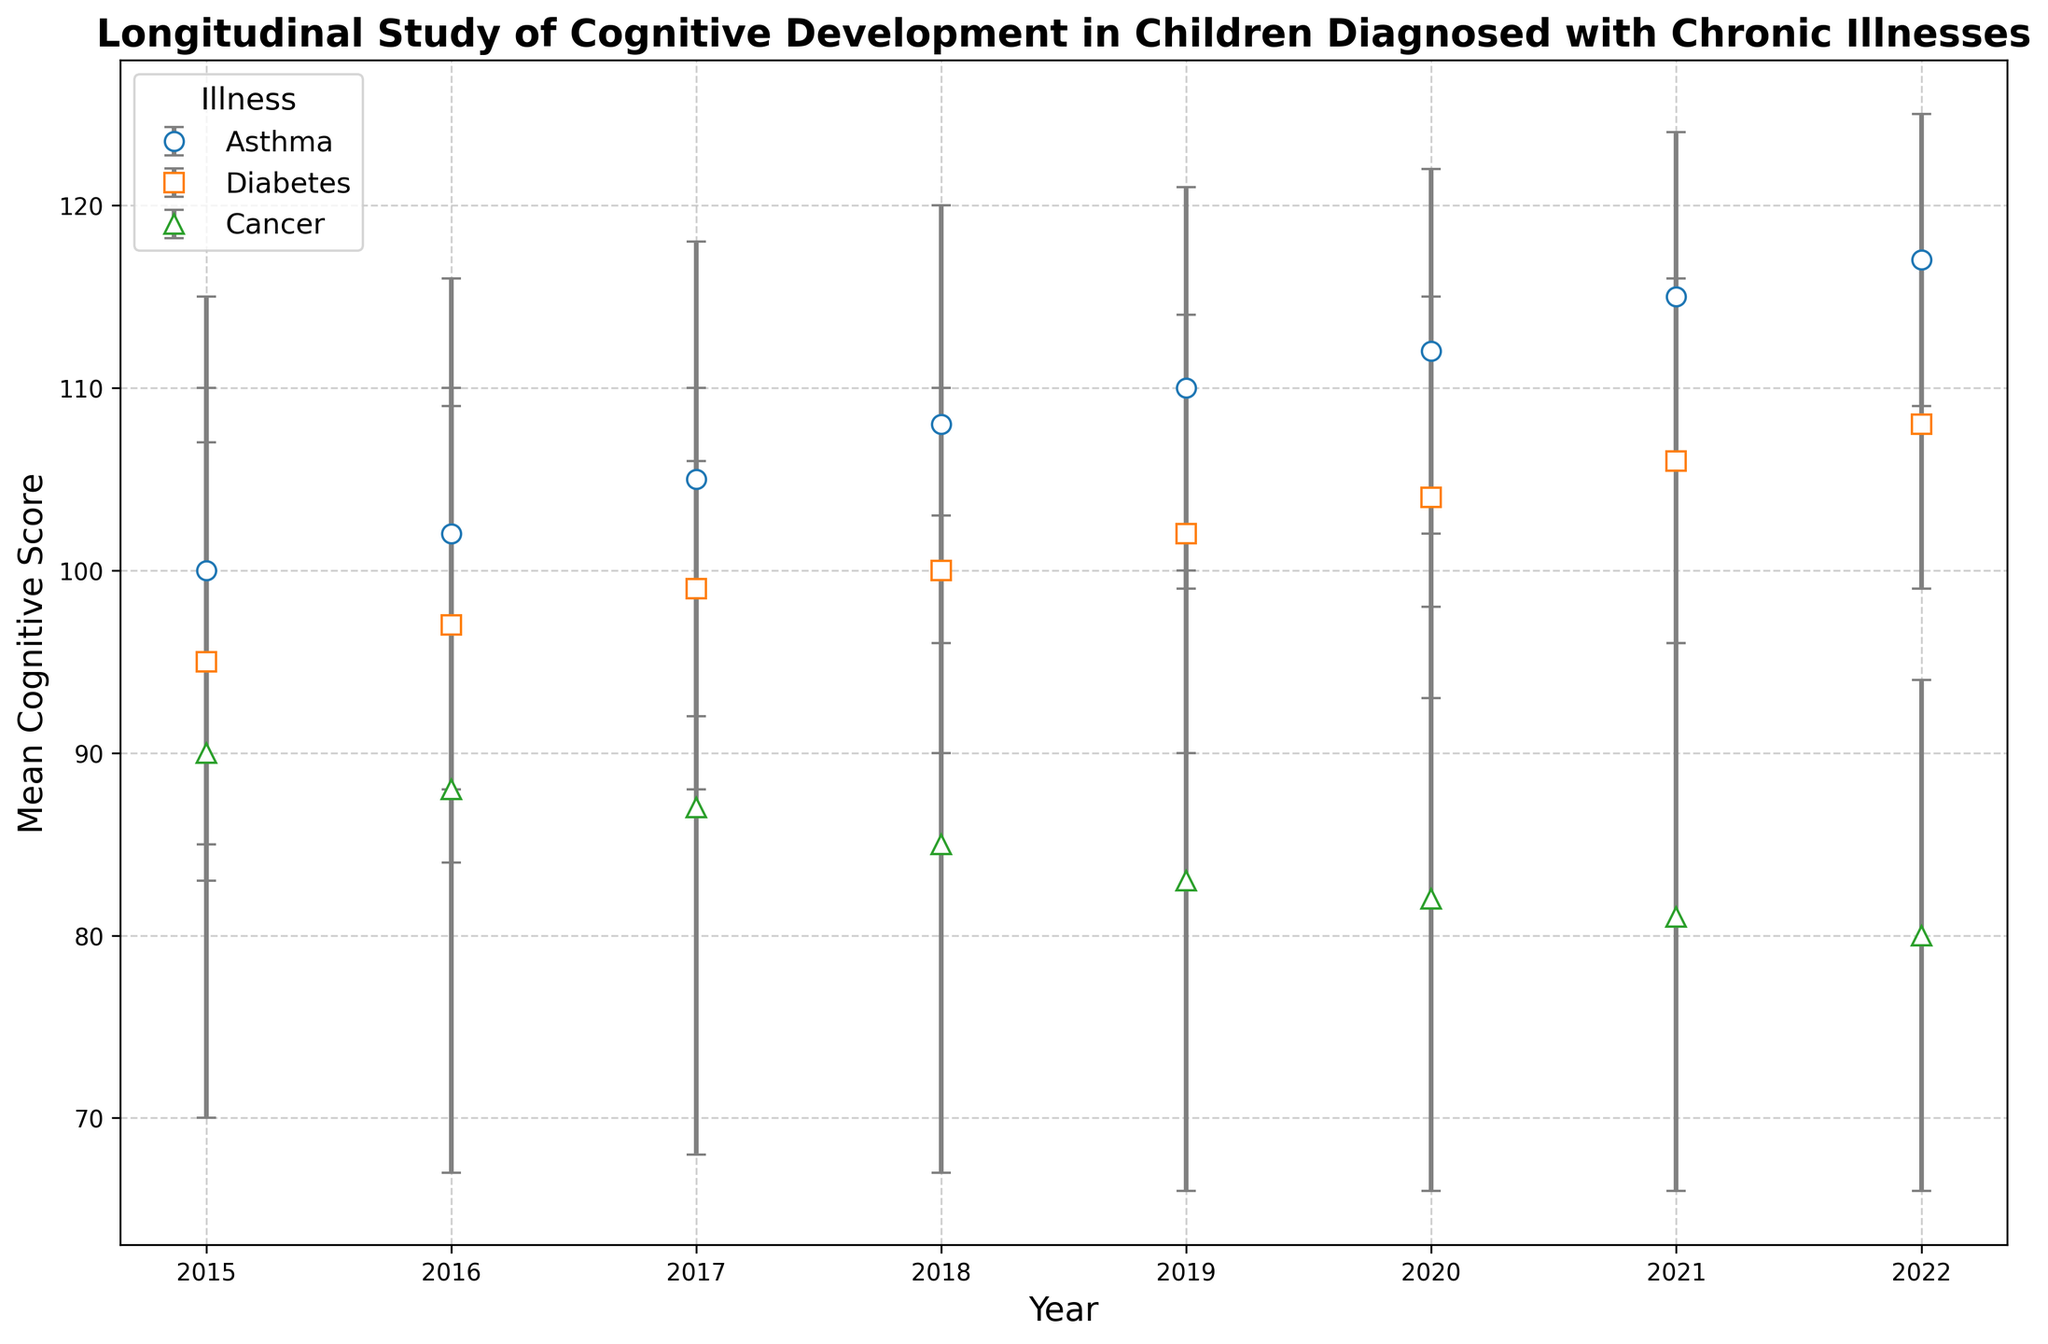Which illness showed the greatest improvement in mean cognitive scores from 2015 to 2022? To determine the greatest improvement, calculate the difference in mean cognitive scores between 2015 and 2022 for each illness: Asthma (117 - 100 = 17), Diabetes (108 - 95 = 13), Cancer (80 - 90 = -10). Asthma shows the greatest improvement.
Answer: Asthma What was the mean cognitive score for children with diabetes in 2020? Locate the data point for Diabetes in the year 2020 on the chart, which shows a mean cognitive score of 104.
Answer: 104 How did the mean cognitive score for children with cancer change from 2019 to 2021? Look at the mean cognitive scores for Cancer in 2019 (83) and 2021 (81), then calculate the difference: 81 - 83 = -2. The mean cognitive score decreased by 2 points.
Answer: Decreased by 2 Comparing 2021, which illness had the highest mean cognitive score, and what was it? In 2021, compare the mean cognitive scores for each illness: Asthma (115), Diabetes (106), Cancer (81). Asthma had the highest mean cognitive score.
Answer: Asthma, 115 What visual marker is used to represent data for children with Asthma? Observe the shapes used for different illnesses. Asthma is represented by circular markers (o).
Answer: Circular markers Which chronic illness consistently had the lowest mean cognitive scores across all years? Review the chart to identify which illness consistently falls at the bottom in terms of mean cognitive score each year. Cancer has the lowest mean cognitive scores throughout the years shown.
Answer: Cancer By how much did the mean cognitive score for children with asthma increase from 2016 to 2018? Calculate the difference in the mean cognitive scores for Asthma between 2016 (102) and 2018 (108): 108 - 102 = 6. The score increased by 6 points.
Answer: Increased by 6 Which year did children with diabetes have a mean cognitive score of 99? Scan the chart to find the year where the mean cognitive score for Diabetes was 99. This occurred in 2017.
Answer: 2017 Comparing the standard deviations, which illness had the most variability in cognitive scores in 2015? Compare the standard deviations for each illness in 2015: Asthma (15), Diabetes (12), Cancer (20). Cancer had the highest standard deviation.
Answer: Cancer 